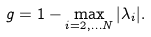<formula> <loc_0><loc_0><loc_500><loc_500>g = 1 - \max _ { i = 2 , \dots N } | \lambda _ { i } | .</formula> 